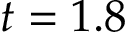<formula> <loc_0><loc_0><loc_500><loc_500>t = 1 . 8</formula> 